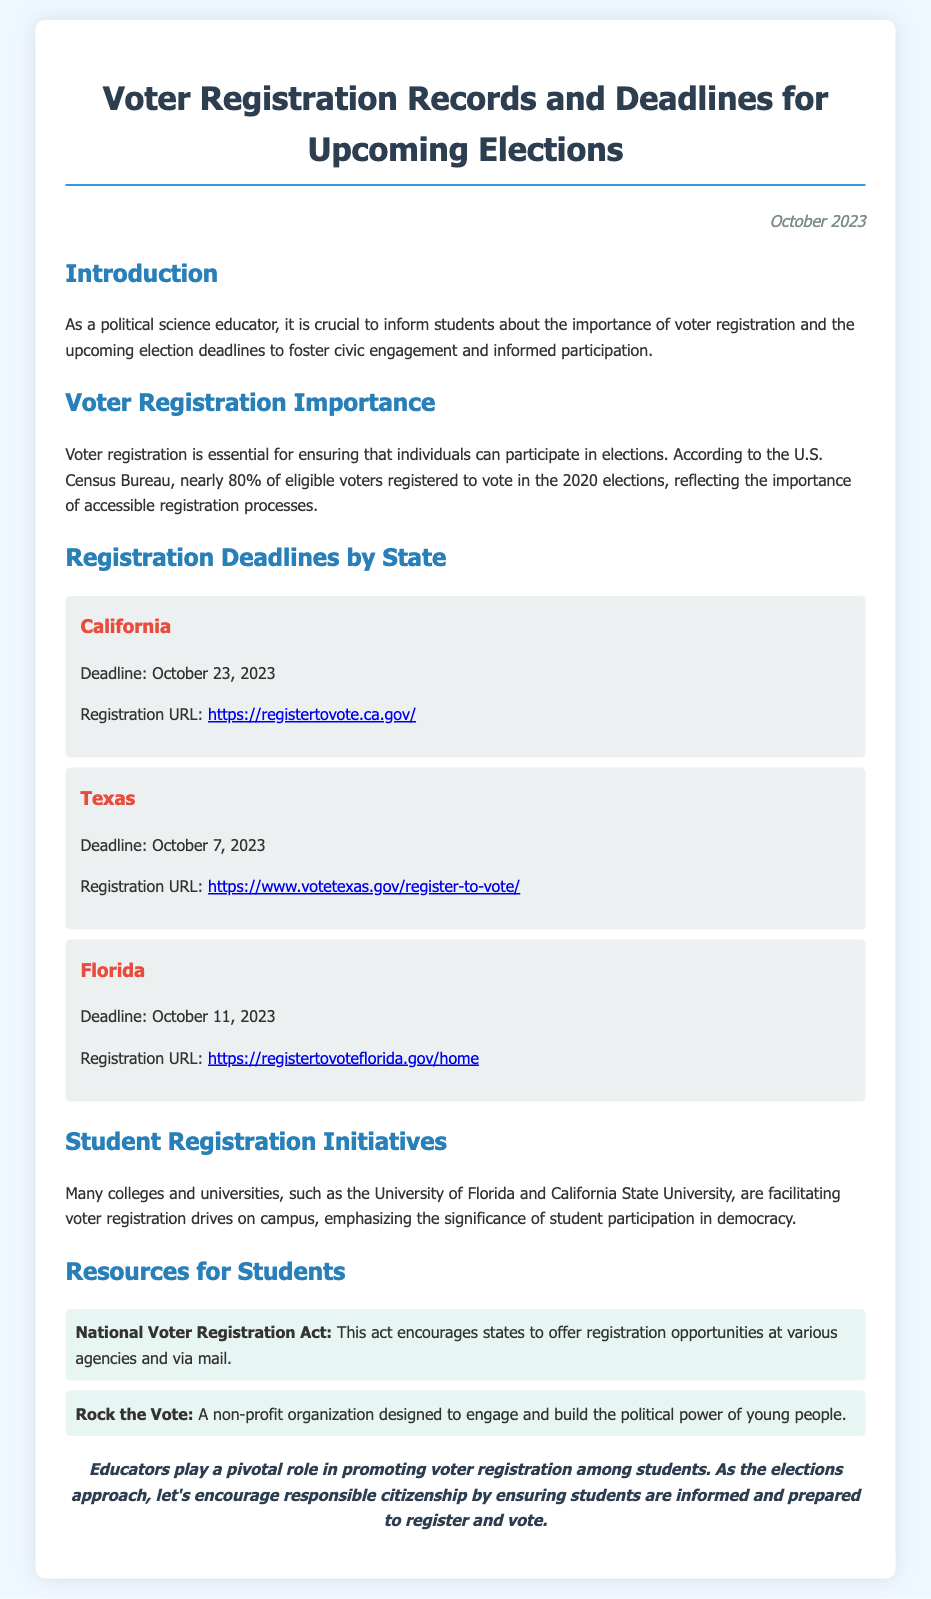What is the registration deadline for California? The registration deadline for California is listed in the document as October 23, 2023.
Answer: October 23, 2023 What is the registration URL for Texas? The document provides the registration URL for Texas as https://www.votetexas.gov/register-to-vote/.
Answer: https://www.votetexas.gov/register-to-vote/ Which act encourages states to offer registration opportunities? The document mentions the National Voter Registration Act as the act that encourages states to offer registration opportunities.
Answer: National Voter Registration Act What is emphasized in student registration initiatives? The document highlights the significance of student participation in democracy as emphasized in student registration initiatives.
Answer: Student participation in democracy How many states' deadlines are provided in the document? The document lists voter registration deadlines for three states: California, Texas, and Florida.
Answer: Three states 